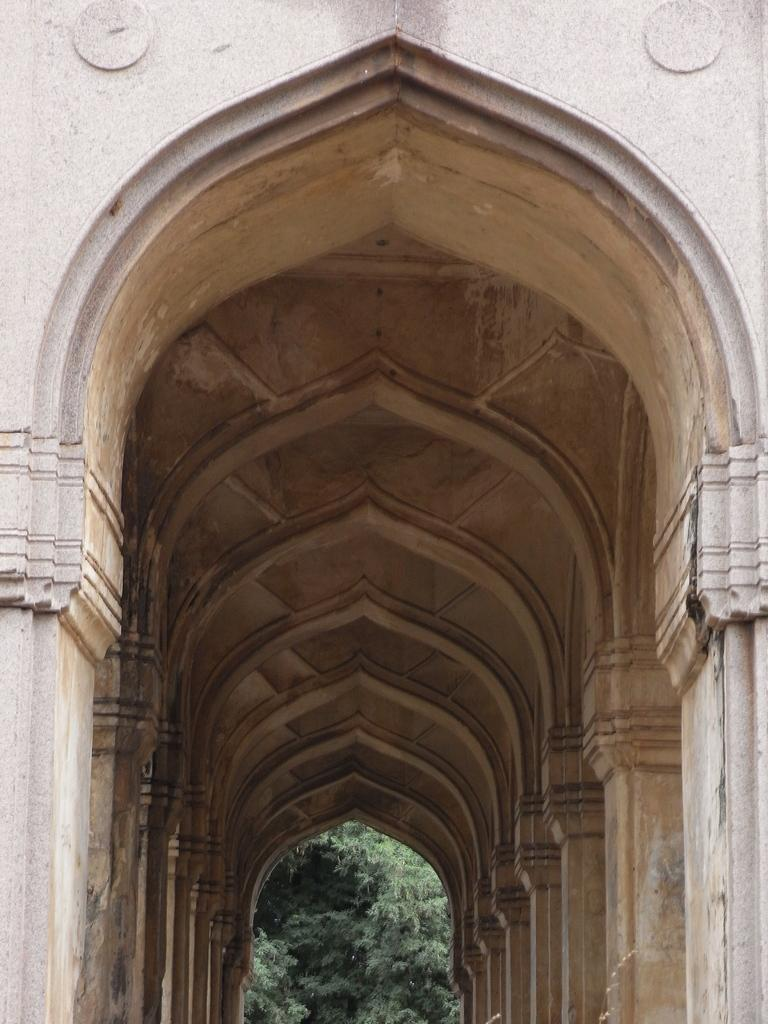What is the main structure in the center of the image? There is a building in the center of the image. What type of natural elements can be seen in the image? There are trees in the image. What architectural features are present in the image? Pillars, a roof, and a wall are present in the image. Are there any other objects or features in the image? Yes, there are a few other objects in the image. What type of apparel is being worn by the babies in the image? There are no babies present in the image, so it is not possible to determine what type of apparel they might be wearing. 